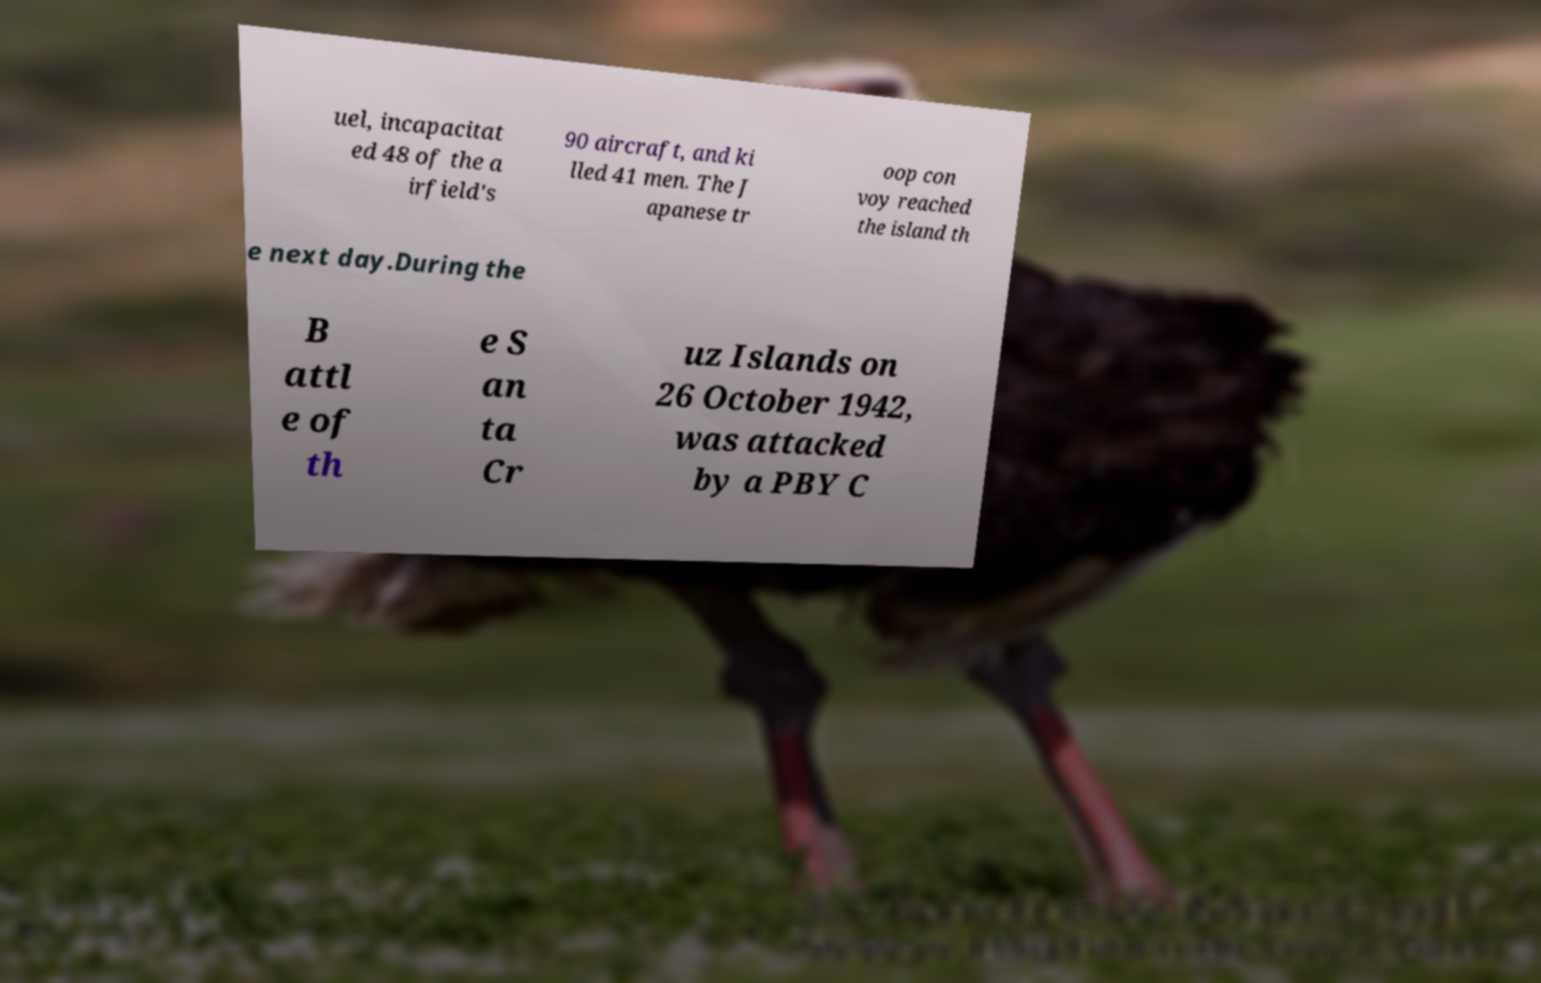What messages or text are displayed in this image? I need them in a readable, typed format. uel, incapacitat ed 48 of the a irfield's 90 aircraft, and ki lled 41 men. The J apanese tr oop con voy reached the island th e next day.During the B attl e of th e S an ta Cr uz Islands on 26 October 1942, was attacked by a PBY C 